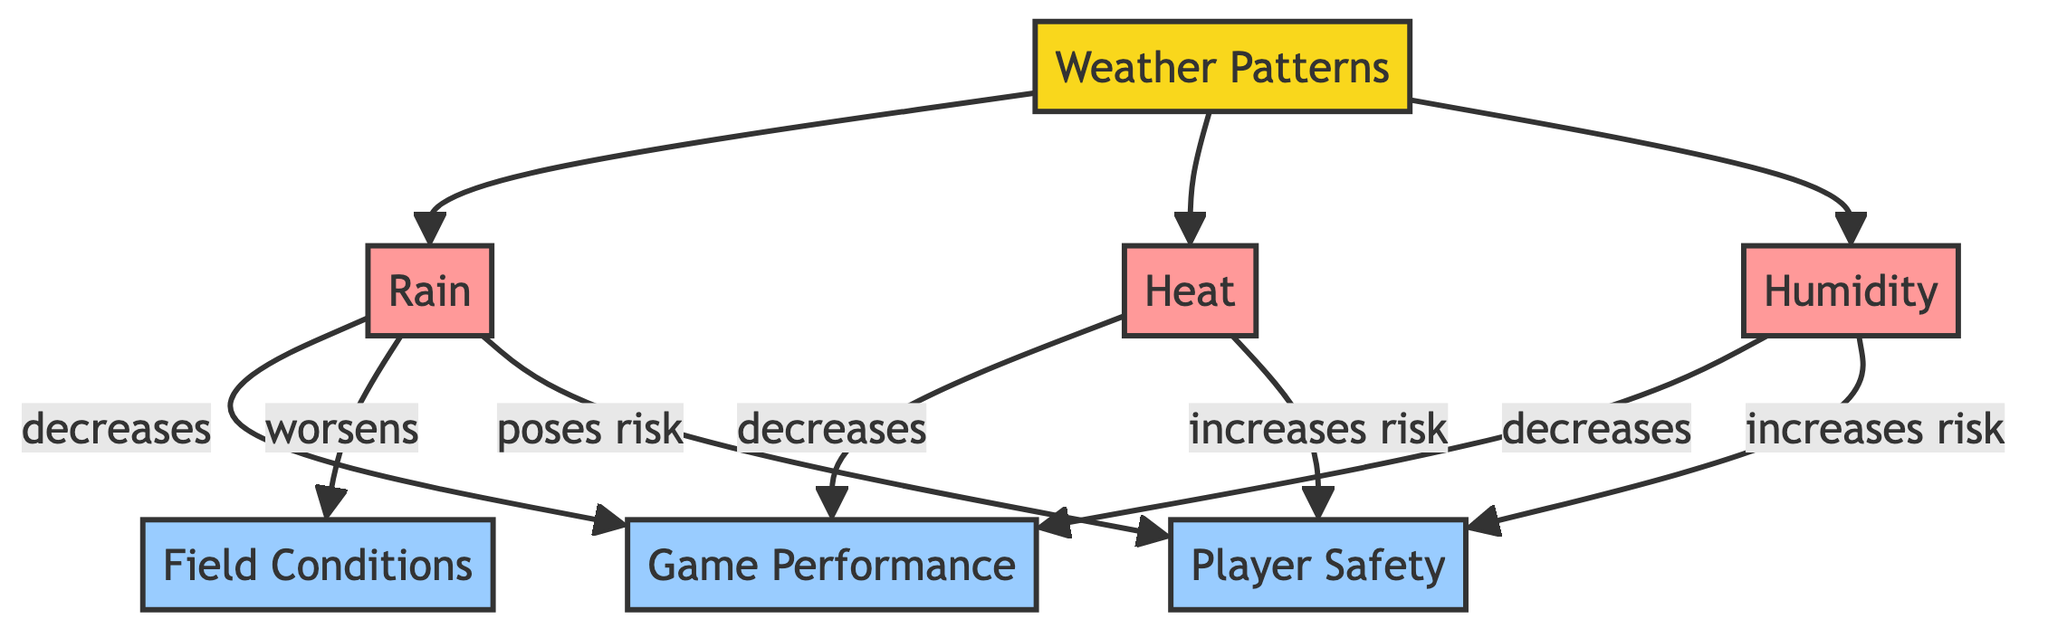What's the primary category in the diagram? The primary category in the diagram is "Weather Patterns," which is indicated at the top of the flowchart. It serves as the main topic under which various weather conditions are categorized.
Answer: Weather Patterns How many weather conditions are listed in the diagram? There are three weather conditions listed in the diagram: Rain, Heat, and Humidity. This can be found in the connections stemming from the "Weather Patterns" node.
Answer: Three What effect does rain have on player safety? Rain poses a risk to player safety, as indicated by the arrow leading from the rain node to the player safety node with the label "poses risk."
Answer: Poses risk What impact does humidity have on game performance? Humidity decreases game performance, which is indicated by the connection from the humidity node to the game performance node labeled "decreases."
Answer: Decreases Which weather condition is linked to increased risk for player safety? Both heat and humidity are linked to increased risk for player safety, as each has an arrow pointing to the player safety node with the label "increases risk." This requires comparing multiple conditions linked to player safety.
Answer: Heat and Humidity What relationship exists between rain and field conditions? Rain worsens field conditions, as indicated by the arrow from the rain node to the field conditions node with the label "worsens." This clearly describes the effect of rain on the state of the field.
Answer: Worsens Which weather condition has the most connections in the diagram? Rain has three connections: it decreases game performance, worsens field conditions, and poses a risk to player safety. This shows rain's overall significant impact compared to other conditions in the diagram.
Answer: Rain How many effects are directly associated with the weather conditions in the diagram? There are six effects associated with the weather conditions: three for each weather condition affecting game performance, field conditions, and player safety overall. This is determined by counting the arrows leading from the condition nodes to the effect nodes.
Answer: Six 